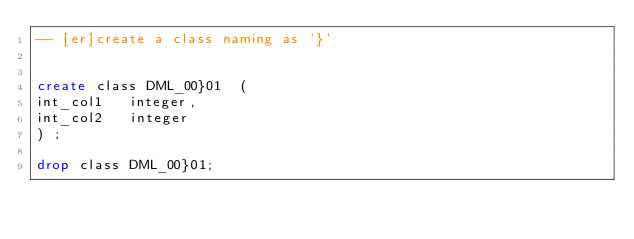Convert code to text. <code><loc_0><loc_0><loc_500><loc_500><_SQL_>-- [er]create a class naming as '}'


create class DML_00}01 	( 
int_col1	 integer,
int_col2	 integer
)	;

drop class DML_00}01;
</code> 